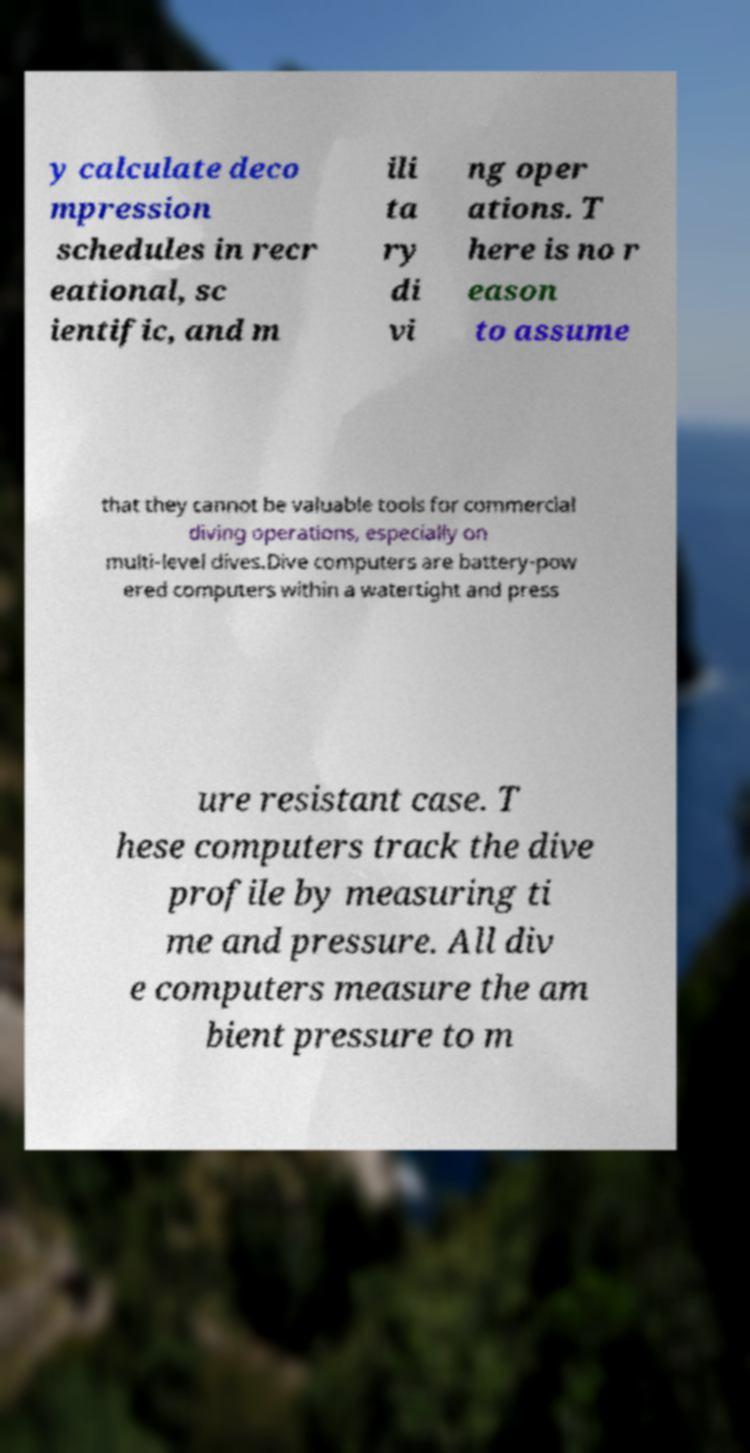I need the written content from this picture converted into text. Can you do that? y calculate deco mpression schedules in recr eational, sc ientific, and m ili ta ry di vi ng oper ations. T here is no r eason to assume that they cannot be valuable tools for commercial diving operations, especially on multi-level dives.Dive computers are battery-pow ered computers within a watertight and press ure resistant case. T hese computers track the dive profile by measuring ti me and pressure. All div e computers measure the am bient pressure to m 